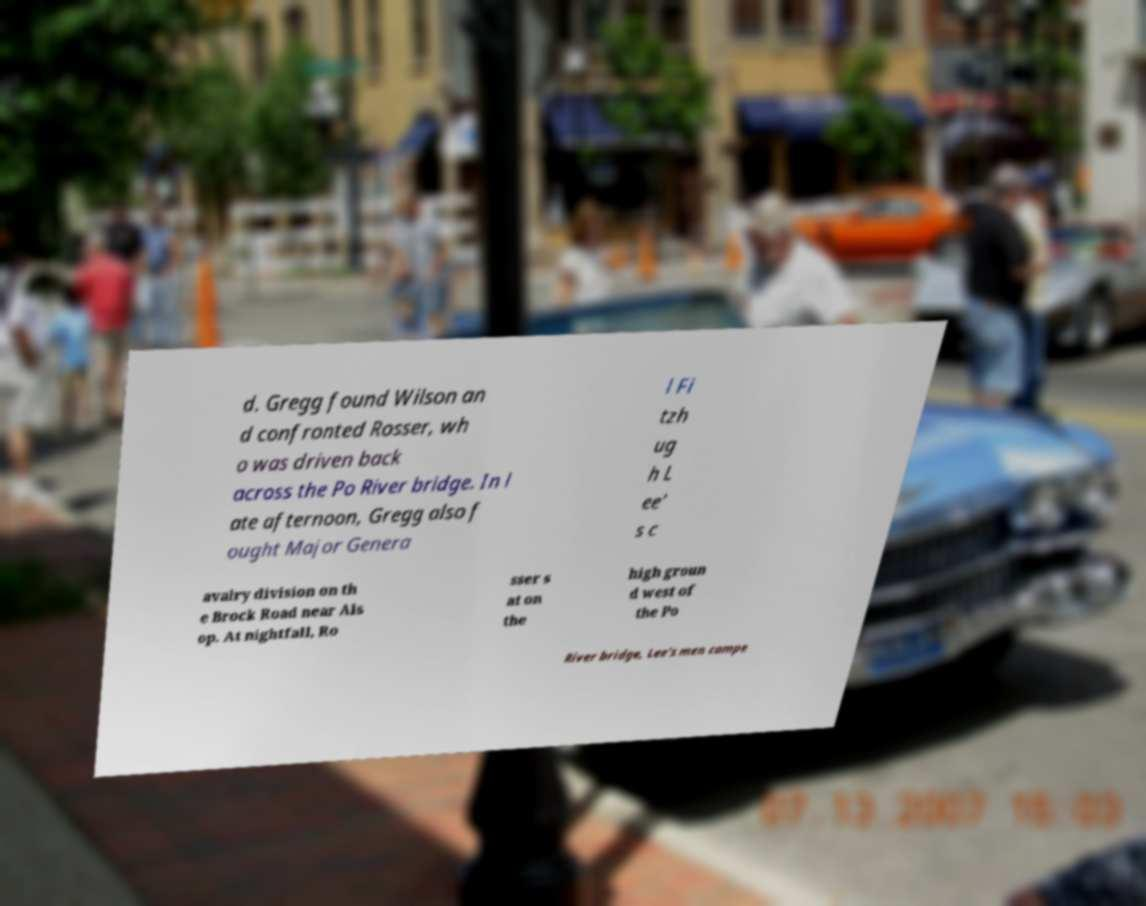For documentation purposes, I need the text within this image transcribed. Could you provide that? d. Gregg found Wilson an d confronted Rosser, wh o was driven back across the Po River bridge. In l ate afternoon, Gregg also f ought Major Genera l Fi tzh ug h L ee' s c avalry division on th e Brock Road near Als op. At nightfall, Ro sser s at on the high groun d west of the Po River bridge, Lee's men campe 